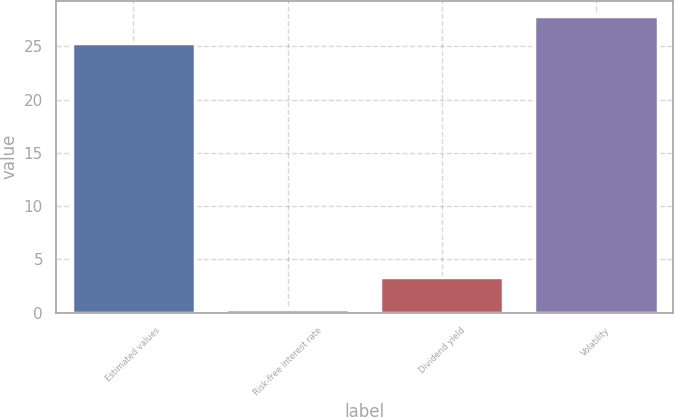Convert chart. <chart><loc_0><loc_0><loc_500><loc_500><bar_chart><fcel>Estimated values<fcel>Risk-free interest rate<fcel>Dividend yield<fcel>Volatility<nl><fcel>25.32<fcel>0.3<fcel>3.3<fcel>27.89<nl></chart> 